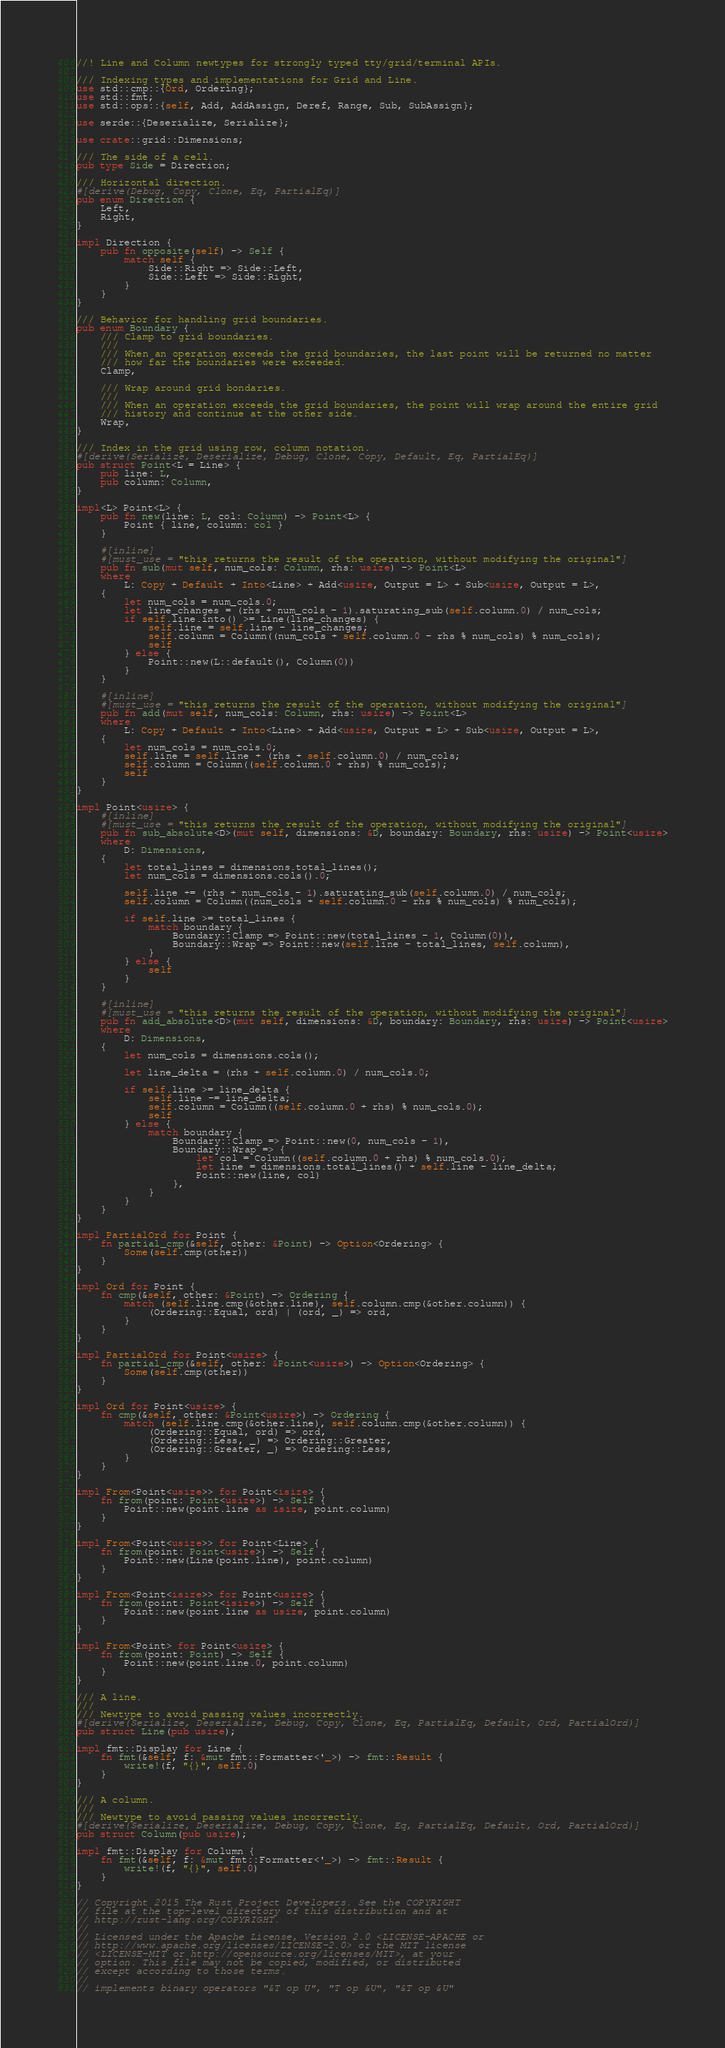Convert code to text. <code><loc_0><loc_0><loc_500><loc_500><_Rust_>//! Line and Column newtypes for strongly typed tty/grid/terminal APIs.

/// Indexing types and implementations for Grid and Line.
use std::cmp::{Ord, Ordering};
use std::fmt;
use std::ops::{self, Add, AddAssign, Deref, Range, Sub, SubAssign};

use serde::{Deserialize, Serialize};

use crate::grid::Dimensions;

/// The side of a cell.
pub type Side = Direction;

/// Horizontal direction.
#[derive(Debug, Copy, Clone, Eq, PartialEq)]
pub enum Direction {
    Left,
    Right,
}

impl Direction {
    pub fn opposite(self) -> Self {
        match self {
            Side::Right => Side::Left,
            Side::Left => Side::Right,
        }
    }
}

/// Behavior for handling grid boundaries.
pub enum Boundary {
    /// Clamp to grid boundaries.
    ///
    /// When an operation exceeds the grid boundaries, the last point will be returned no matter
    /// how far the boundaries were exceeded.
    Clamp,

    /// Wrap around grid bondaries.
    ///
    /// When an operation exceeds the grid boundaries, the point will wrap around the entire grid
    /// history and continue at the other side.
    Wrap,
}

/// Index in the grid using row, column notation.
#[derive(Serialize, Deserialize, Debug, Clone, Copy, Default, Eq, PartialEq)]
pub struct Point<L = Line> {
    pub line: L,
    pub column: Column,
}

impl<L> Point<L> {
    pub fn new(line: L, col: Column) -> Point<L> {
        Point { line, column: col }
    }

    #[inline]
    #[must_use = "this returns the result of the operation, without modifying the original"]
    pub fn sub(mut self, num_cols: Column, rhs: usize) -> Point<L>
    where
        L: Copy + Default + Into<Line> + Add<usize, Output = L> + Sub<usize, Output = L>,
    {
        let num_cols = num_cols.0;
        let line_changes = (rhs + num_cols - 1).saturating_sub(self.column.0) / num_cols;
        if self.line.into() >= Line(line_changes) {
            self.line = self.line - line_changes;
            self.column = Column((num_cols + self.column.0 - rhs % num_cols) % num_cols);
            self
        } else {
            Point::new(L::default(), Column(0))
        }
    }

    #[inline]
    #[must_use = "this returns the result of the operation, without modifying the original"]
    pub fn add(mut self, num_cols: Column, rhs: usize) -> Point<L>
    where
        L: Copy + Default + Into<Line> + Add<usize, Output = L> + Sub<usize, Output = L>,
    {
        let num_cols = num_cols.0;
        self.line = self.line + (rhs + self.column.0) / num_cols;
        self.column = Column((self.column.0 + rhs) % num_cols);
        self
    }
}

impl Point<usize> {
    #[inline]
    #[must_use = "this returns the result of the operation, without modifying the original"]
    pub fn sub_absolute<D>(mut self, dimensions: &D, boundary: Boundary, rhs: usize) -> Point<usize>
    where
        D: Dimensions,
    {
        let total_lines = dimensions.total_lines();
        let num_cols = dimensions.cols().0;

        self.line += (rhs + num_cols - 1).saturating_sub(self.column.0) / num_cols;
        self.column = Column((num_cols + self.column.0 - rhs % num_cols) % num_cols);

        if self.line >= total_lines {
            match boundary {
                Boundary::Clamp => Point::new(total_lines - 1, Column(0)),
                Boundary::Wrap => Point::new(self.line - total_lines, self.column),
            }
        } else {
            self
        }
    }

    #[inline]
    #[must_use = "this returns the result of the operation, without modifying the original"]
    pub fn add_absolute<D>(mut self, dimensions: &D, boundary: Boundary, rhs: usize) -> Point<usize>
    where
        D: Dimensions,
    {
        let num_cols = dimensions.cols();

        let line_delta = (rhs + self.column.0) / num_cols.0;

        if self.line >= line_delta {
            self.line -= line_delta;
            self.column = Column((self.column.0 + rhs) % num_cols.0);
            self
        } else {
            match boundary {
                Boundary::Clamp => Point::new(0, num_cols - 1),
                Boundary::Wrap => {
                    let col = Column((self.column.0 + rhs) % num_cols.0);
                    let line = dimensions.total_lines() + self.line - line_delta;
                    Point::new(line, col)
                },
            }
        }
    }
}

impl PartialOrd for Point {
    fn partial_cmp(&self, other: &Point) -> Option<Ordering> {
        Some(self.cmp(other))
    }
}

impl Ord for Point {
    fn cmp(&self, other: &Point) -> Ordering {
        match (self.line.cmp(&other.line), self.column.cmp(&other.column)) {
            (Ordering::Equal, ord) | (ord, _) => ord,
        }
    }
}

impl PartialOrd for Point<usize> {
    fn partial_cmp(&self, other: &Point<usize>) -> Option<Ordering> {
        Some(self.cmp(other))
    }
}

impl Ord for Point<usize> {
    fn cmp(&self, other: &Point<usize>) -> Ordering {
        match (self.line.cmp(&other.line), self.column.cmp(&other.column)) {
            (Ordering::Equal, ord) => ord,
            (Ordering::Less, _) => Ordering::Greater,
            (Ordering::Greater, _) => Ordering::Less,
        }
    }
}

impl From<Point<usize>> for Point<isize> {
    fn from(point: Point<usize>) -> Self {
        Point::new(point.line as isize, point.column)
    }
}

impl From<Point<usize>> for Point<Line> {
    fn from(point: Point<usize>) -> Self {
        Point::new(Line(point.line), point.column)
    }
}

impl From<Point<isize>> for Point<usize> {
    fn from(point: Point<isize>) -> Self {
        Point::new(point.line as usize, point.column)
    }
}

impl From<Point> for Point<usize> {
    fn from(point: Point) -> Self {
        Point::new(point.line.0, point.column)
    }
}

/// A line.
///
/// Newtype to avoid passing values incorrectly.
#[derive(Serialize, Deserialize, Debug, Copy, Clone, Eq, PartialEq, Default, Ord, PartialOrd)]
pub struct Line(pub usize);

impl fmt::Display for Line {
    fn fmt(&self, f: &mut fmt::Formatter<'_>) -> fmt::Result {
        write!(f, "{}", self.0)
    }
}

/// A column.
///
/// Newtype to avoid passing values incorrectly.
#[derive(Serialize, Deserialize, Debug, Copy, Clone, Eq, PartialEq, Default, Ord, PartialOrd)]
pub struct Column(pub usize);

impl fmt::Display for Column {
    fn fmt(&self, f: &mut fmt::Formatter<'_>) -> fmt::Result {
        write!(f, "{}", self.0)
    }
}

// Copyright 2015 The Rust Project Developers. See the COPYRIGHT
// file at the top-level directory of this distribution and at
// http://rust-lang.org/COPYRIGHT.
//
// Licensed under the Apache License, Version 2.0 <LICENSE-APACHE or
// http://www.apache.org/licenses/LICENSE-2.0> or the MIT license
// <LICENSE-MIT or http://opensource.org/licenses/MIT>, at your
// option. This file may not be copied, modified, or distributed
// except according to those terms.
//
// implements binary operators "&T op U", "T op &U", "&T op &U"</code> 